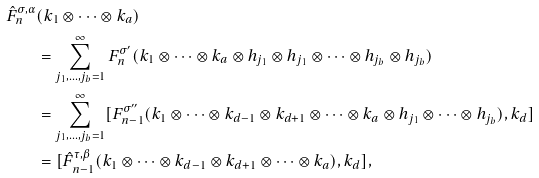Convert formula to latex. <formula><loc_0><loc_0><loc_500><loc_500>\hat { F } _ { n } ^ { \sigma , \alpha } & ( k _ { 1 } \otimes \cdots \otimes k _ { a } ) \\ & = \sum _ { j _ { 1 } , \dots , j _ { b } = 1 } ^ { \infty } F _ { n } ^ { \sigma ^ { \prime } } ( k _ { 1 } \otimes \cdots \otimes k _ { a } \otimes h _ { j _ { 1 } } \otimes h _ { j _ { 1 } } \otimes \cdots \otimes h _ { j _ { b } } \otimes h _ { j _ { b } } ) \\ & = \sum _ { j _ { 1 } , \dots , j _ { b } = 1 } ^ { \infty } [ F _ { n - 1 } ^ { \sigma ^ { \prime \prime } } ( k _ { 1 } \otimes \cdots \otimes k _ { d - 1 } \otimes k _ { d + 1 } \otimes \cdots \otimes k _ { a } \otimes h _ { j _ { 1 } } \otimes \cdots \otimes h _ { j _ { b } } ) , k _ { d } ] \\ & = [ \hat { F } _ { n - 1 } ^ { \tau , \beta } ( k _ { 1 } \otimes \cdots \otimes k _ { d - 1 } \otimes k _ { d + 1 } \otimes \cdots \otimes k _ { a } ) , k _ { d } ] ,</formula> 